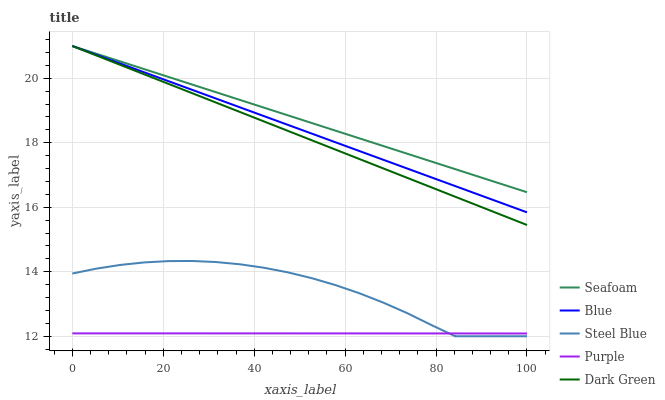Does Purple have the minimum area under the curve?
Answer yes or no. Yes. Does Seafoam have the maximum area under the curve?
Answer yes or no. Yes. Does Dark Green have the minimum area under the curve?
Answer yes or no. No. Does Dark Green have the maximum area under the curve?
Answer yes or no. No. Is Dark Green the smoothest?
Answer yes or no. Yes. Is Steel Blue the roughest?
Answer yes or no. Yes. Is Purple the smoothest?
Answer yes or no. No. Is Purple the roughest?
Answer yes or no. No. Does Purple have the lowest value?
Answer yes or no. No. Does Seafoam have the highest value?
Answer yes or no. Yes. Does Purple have the highest value?
Answer yes or no. No. Is Purple less than Blue?
Answer yes or no. Yes. Is Dark Green greater than Purple?
Answer yes or no. Yes. Does Blue intersect Seafoam?
Answer yes or no. Yes. Is Blue less than Seafoam?
Answer yes or no. No. Is Blue greater than Seafoam?
Answer yes or no. No. Does Purple intersect Blue?
Answer yes or no. No. 